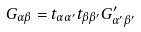Convert formula to latex. <formula><loc_0><loc_0><loc_500><loc_500>G _ { \alpha \beta } = t _ { \alpha \alpha ^ { \prime } } t _ { \beta \beta ^ { \prime } } G ^ { \prime } _ { \alpha ^ { \prime } \beta ^ { \prime } }</formula> 